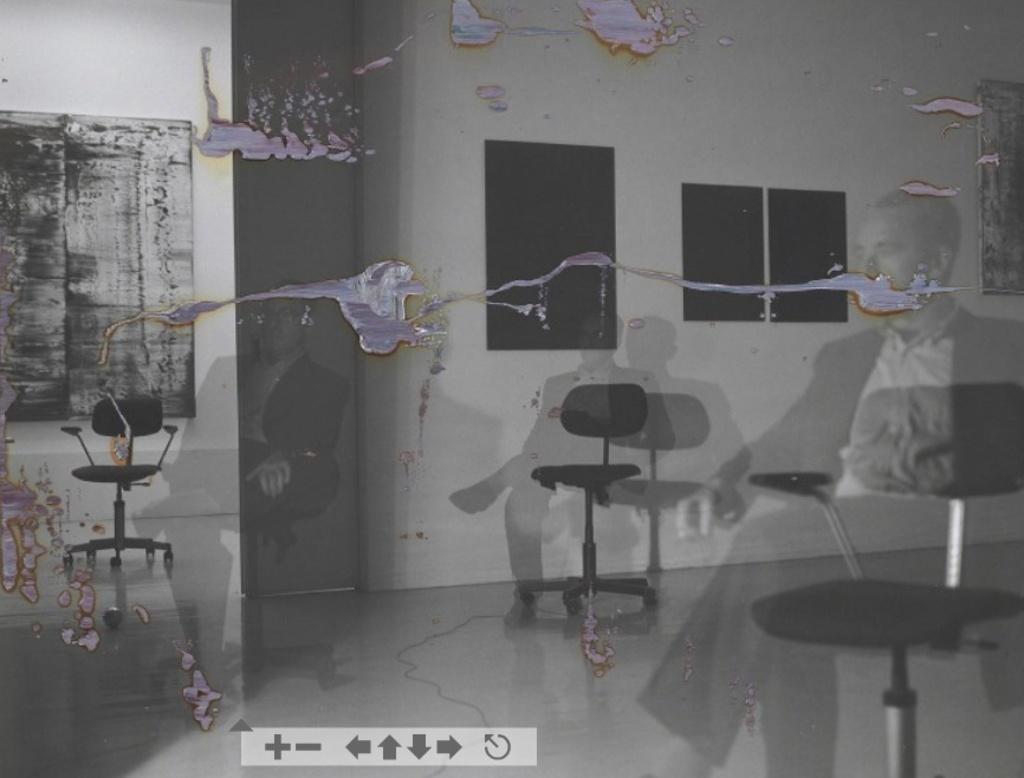Could you give a brief overview of what you see in this image? This picture seems to be an edited image and we can see the reflections of persons seems to be sitting on the chairs and we can see the chairs, wall and some other items. 